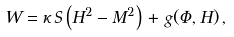Convert formula to latex. <formula><loc_0><loc_0><loc_500><loc_500>W = \kappa \, S \left ( H ^ { 2 } - M ^ { 2 } \right ) \, + \, g ( \Phi , H ) \, ,</formula> 